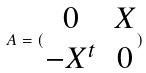<formula> <loc_0><loc_0><loc_500><loc_500>A = ( \begin{matrix} 0 & X \\ - X ^ { t } & 0 \end{matrix} )</formula> 